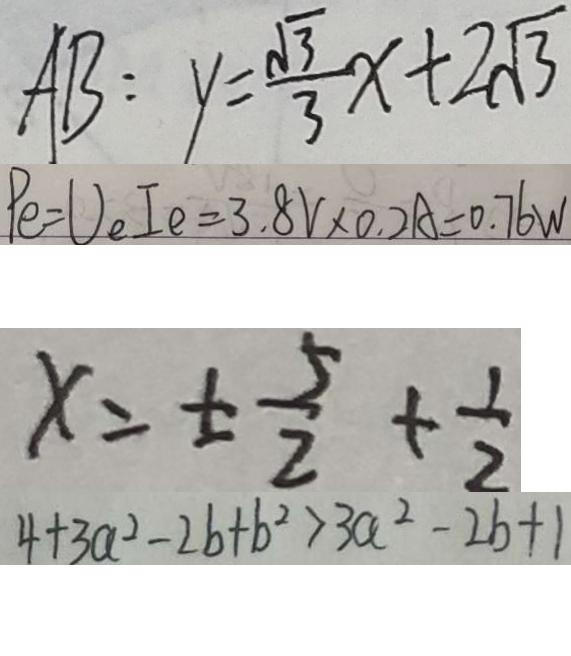Convert formula to latex. <formula><loc_0><loc_0><loc_500><loc_500>A B : y = \frac { \sqrt { 3 } } { 3 } x + 2 \sqrt { 3 } 
 P e = U _ { e } I e = 3 . 8 V \times 0 . 2 A = 0 . 7 6 W 
 x = \pm \frac { 5 } { 2 } + \frac { 1 } { 2 } 
 4 + 3 a ^ { 2 } - 2 b + b ^ { 2 } > 3 a ^ { 2 } - 2 b + 1</formula> 